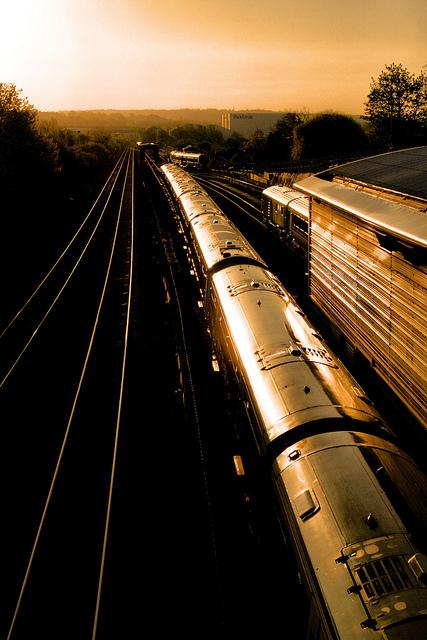Is this train in a tunnel?
Short answer required. No. How many trains are visible?
Keep it brief. 3. What time of day was this taken?
Short answer required. Dawn. 